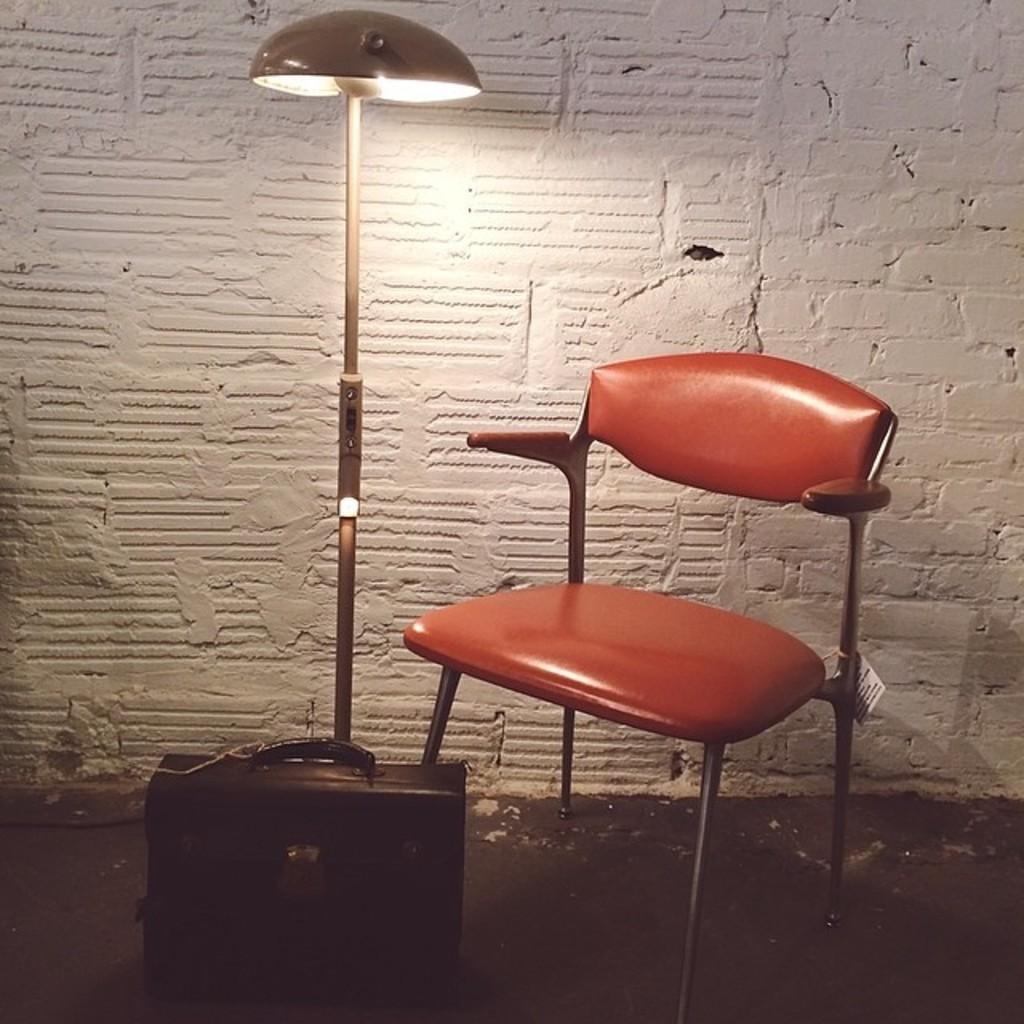Please provide a concise description of this image. In this image I see a chair, a suitcase and a lamp. In the background I see the white wall. 